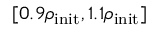Convert formula to latex. <formula><loc_0><loc_0><loc_500><loc_500>[ 0 . 9 \rho _ { i n i t } , 1 . 1 \rho _ { i n i t } ]</formula> 